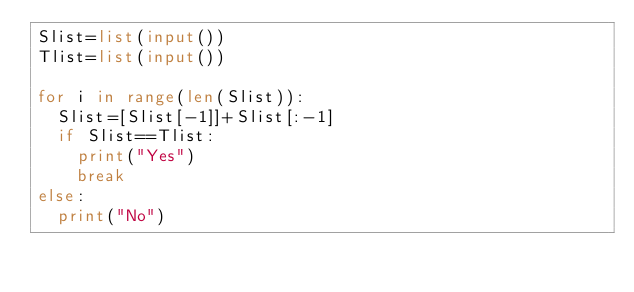<code> <loc_0><loc_0><loc_500><loc_500><_Python_>Slist=list(input())
Tlist=list(input())

for i in range(len(Slist)):
  Slist=[Slist[-1]]+Slist[:-1]
  if Slist==Tlist:
    print("Yes")
    break
else:
  print("No")</code> 